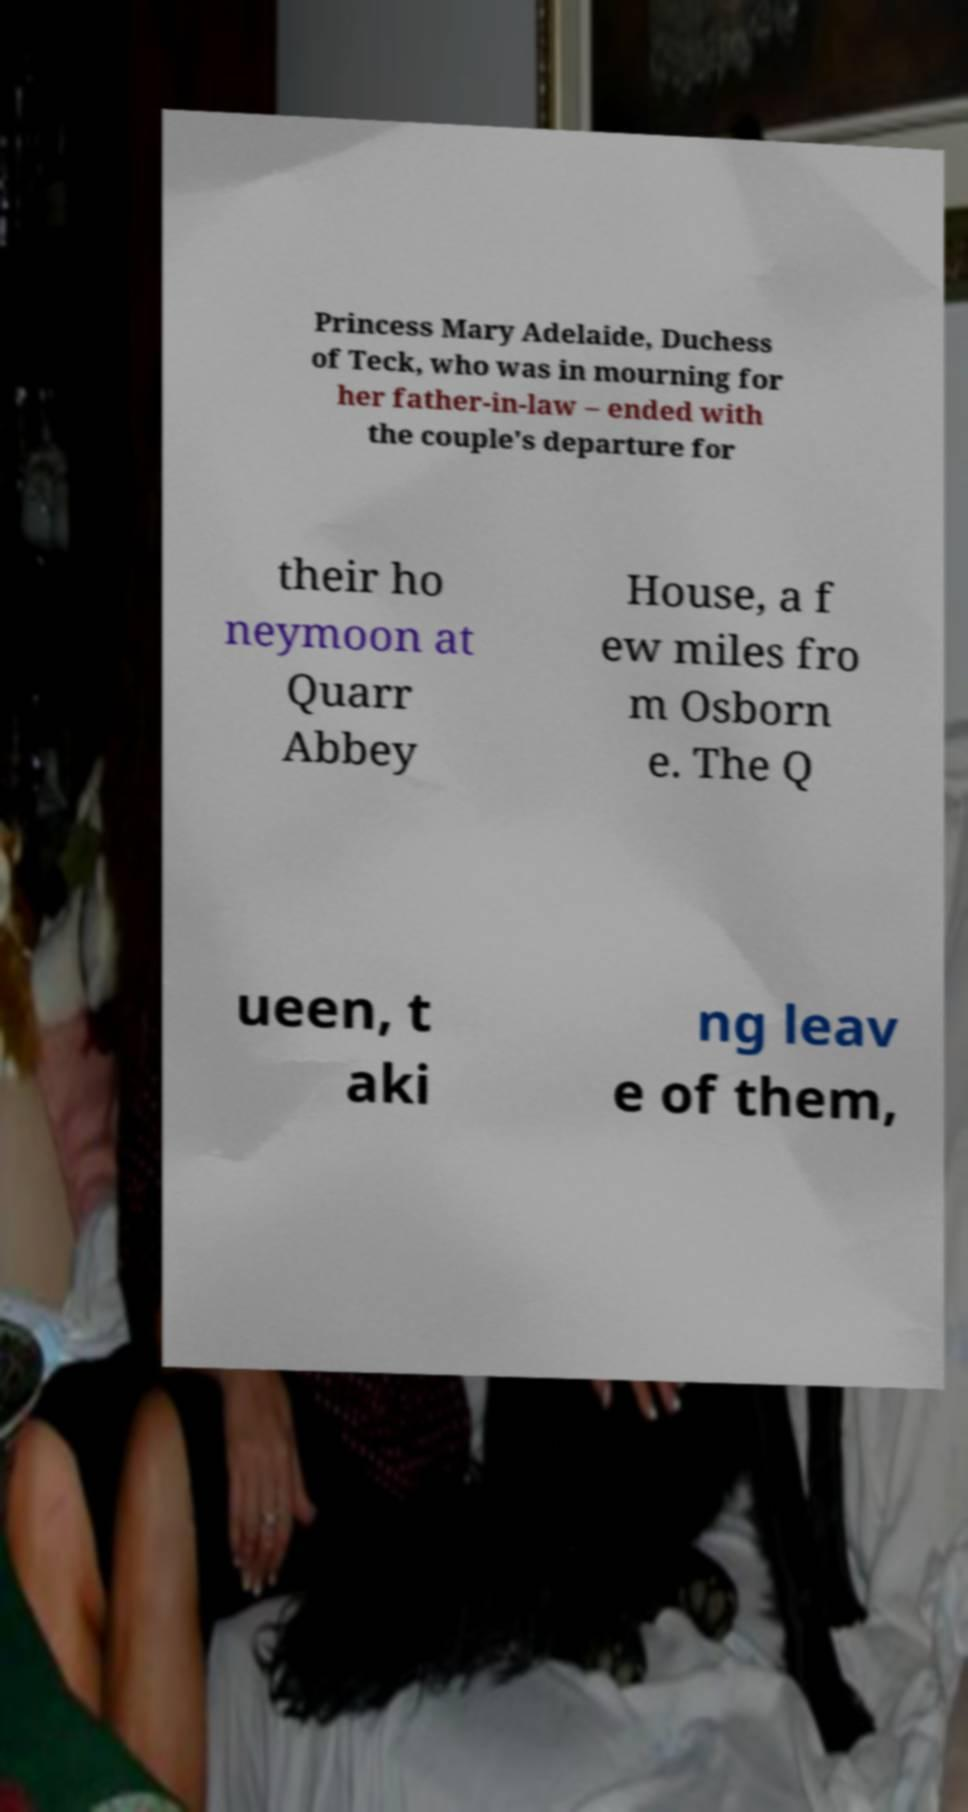Can you accurately transcribe the text from the provided image for me? Princess Mary Adelaide, Duchess of Teck, who was in mourning for her father-in-law – ended with the couple's departure for their ho neymoon at Quarr Abbey House, a f ew miles fro m Osborn e. The Q ueen, t aki ng leav e of them, 